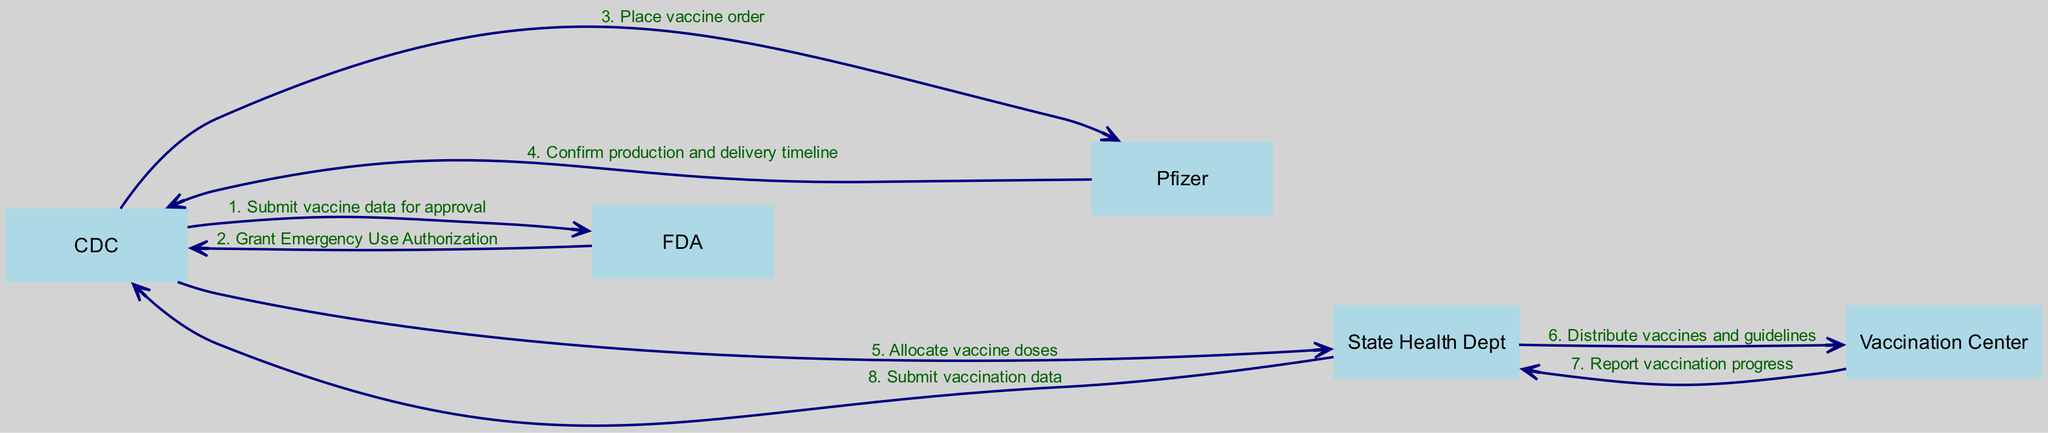What is the first action taken in the sequence? The first action in the sequence is initiated by the CDC, which submits vaccine data for approval to the FDA.
Answer: Submit vaccine data for approval How many actors are in the diagram? By analyzing the diagram, we can count five actors involved: CDC, FDA, Pfizer, State Health Dept, and Vaccination Center.
Answer: 5 What message is sent from Pfizer to CDC? The message sent from Pfizer to CDC is to confirm the production and delivery timeline of the vaccine.
Answer: Confirm production and delivery timeline Who grants Emergency Use Authorization? The FDA is the entity that grants Emergency Use Authorization after receiving the vaccine data from the CDC.
Answer: FDA What is the last action performed in the sequence? The last action performed involves the State Health Department submitting vaccination data to the CDC after the vaccination is in progress.
Answer: Submit vaccination data How many messages are exchanged from CDC to State Health Dept? In the diagram, there are two messages exchanged from CDC to State Health Dept: one for allocating vaccine doses and another for submitting vaccination progress.
Answer: 2 What does the State Health Dept distribute to the Vaccination Center? The State Health Dept distributes vaccines and guidelines to the Vaccination Center in a crucial step in the rollout process.
Answer: Distribute vaccines and guidelines Describe the direction of the message flow between the Vaccination Center and State Health Dept. The message flow is directed from the Vaccination Center to State Health Dept, specifically for reporting vaccination progress back to them.
Answer: From Vaccination Center to State Health Dept What role does Pfizer play in this process? Pfizer's role is to produce the vaccine and confirm the production and delivery timeline after the order is placed by CDC.
Answer: Vaccine production and delivery confirmation 